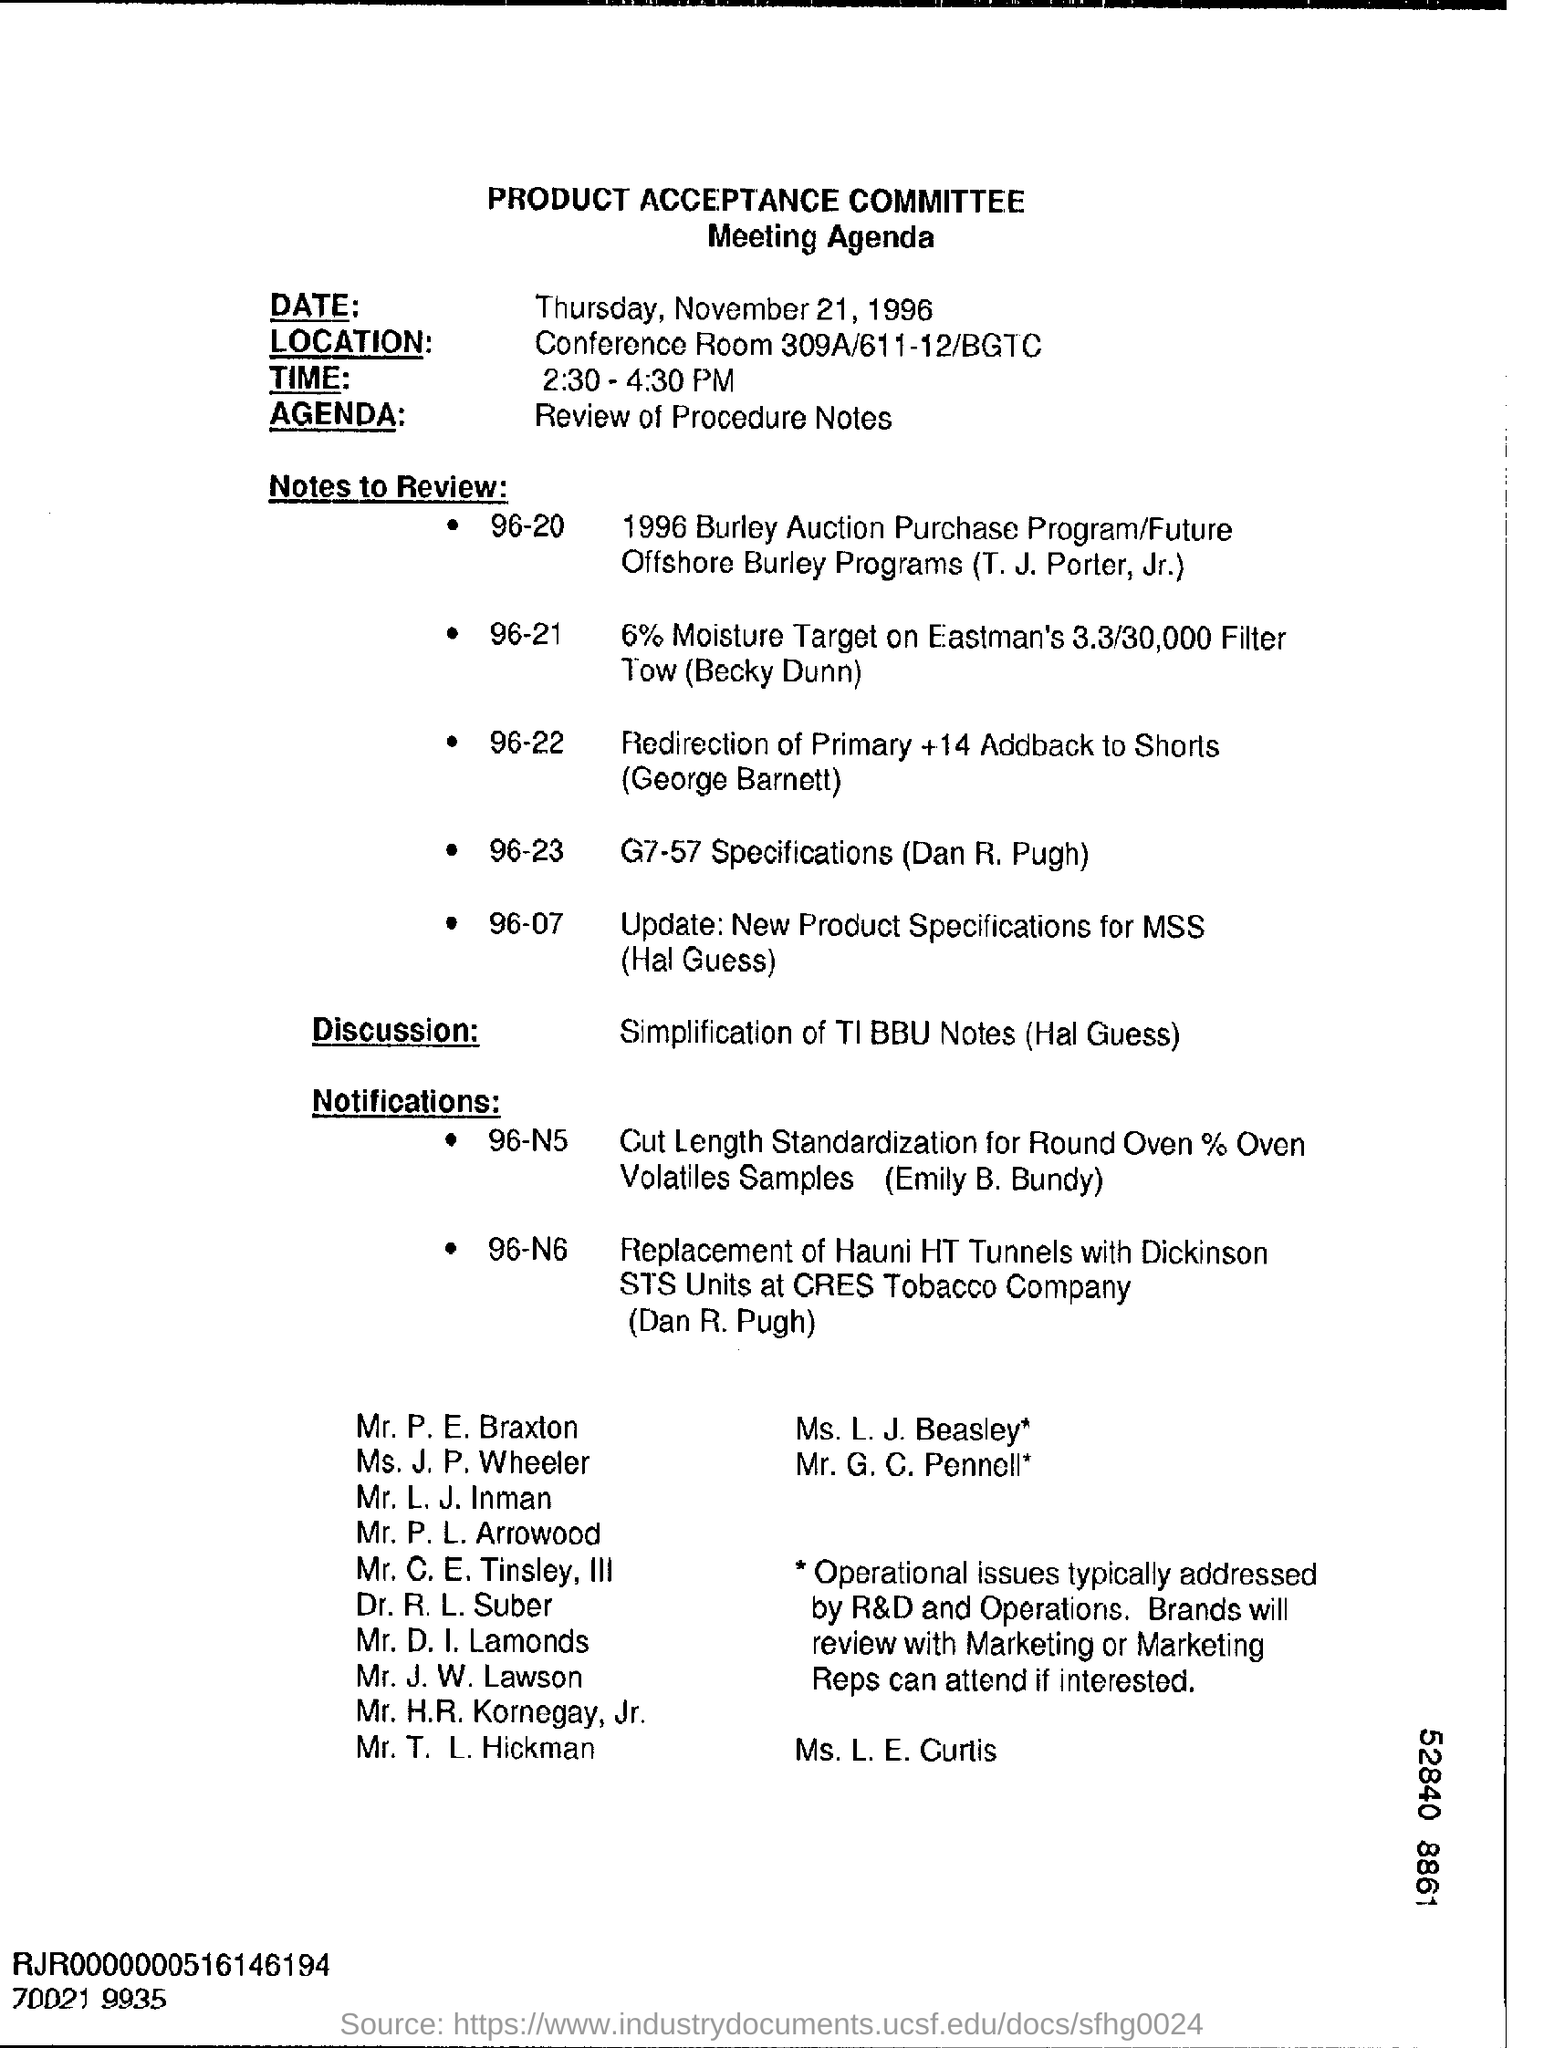Specify some key components in this picture. The timing of the meeting is from 2:30 PM to 4:30 PM. The date mentioned at the top of the document is Thursday, November 21, 1996. The location of the conference is in Conference Room 309A/611-12/BGTC. 